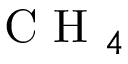Convert formula to latex. <formula><loc_0><loc_0><loc_500><loc_500>{ C H _ { 4 } }</formula> 